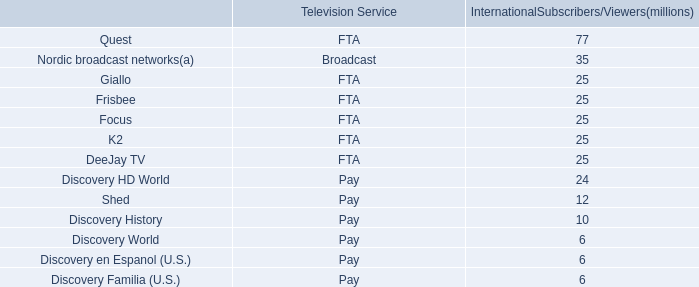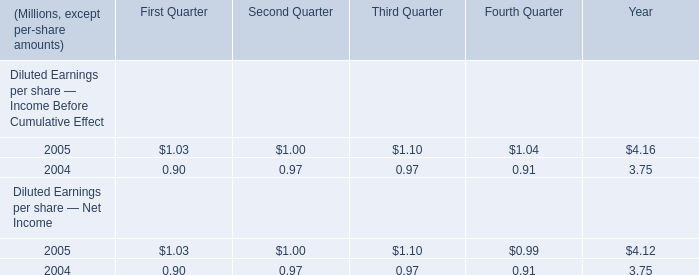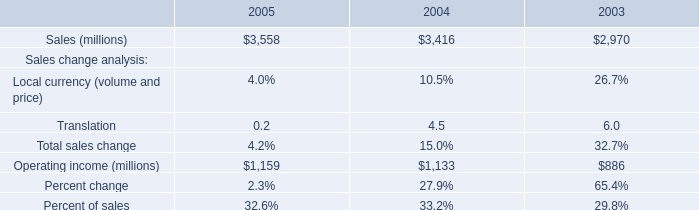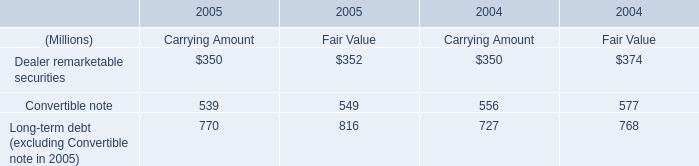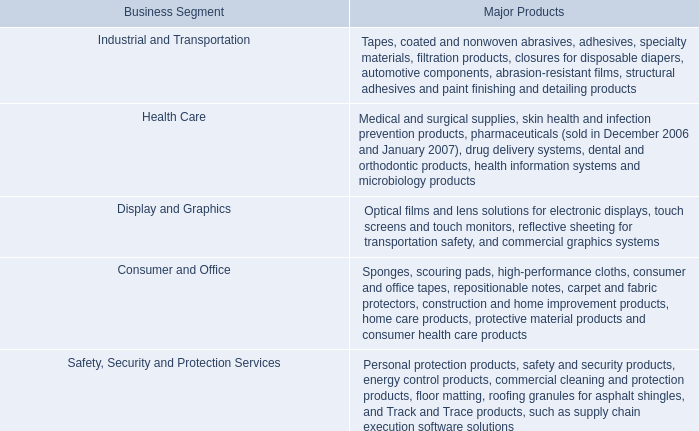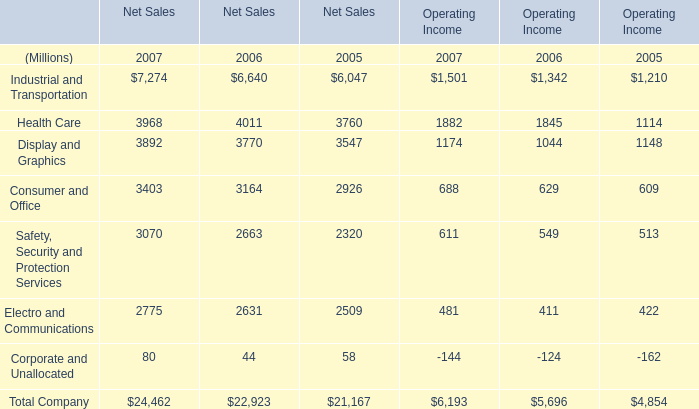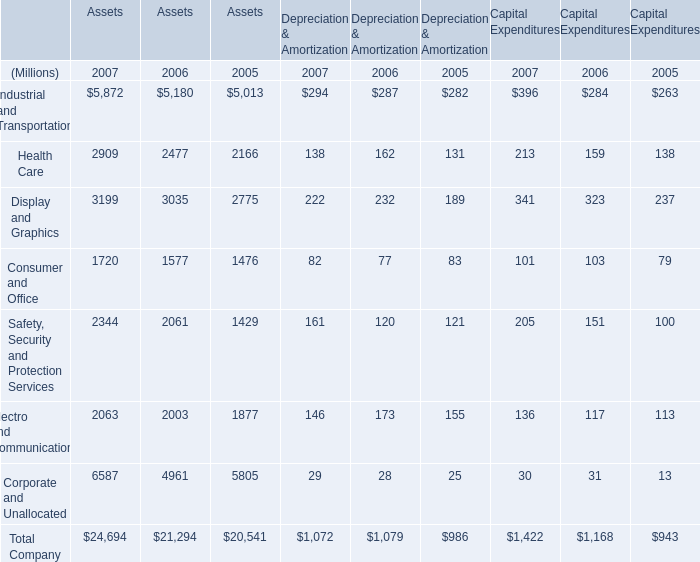What was the total amount of Health Care for Net Sales? (in million) 
Computations: ((3968 + 4011) + 3760)
Answer: 11739.0. 